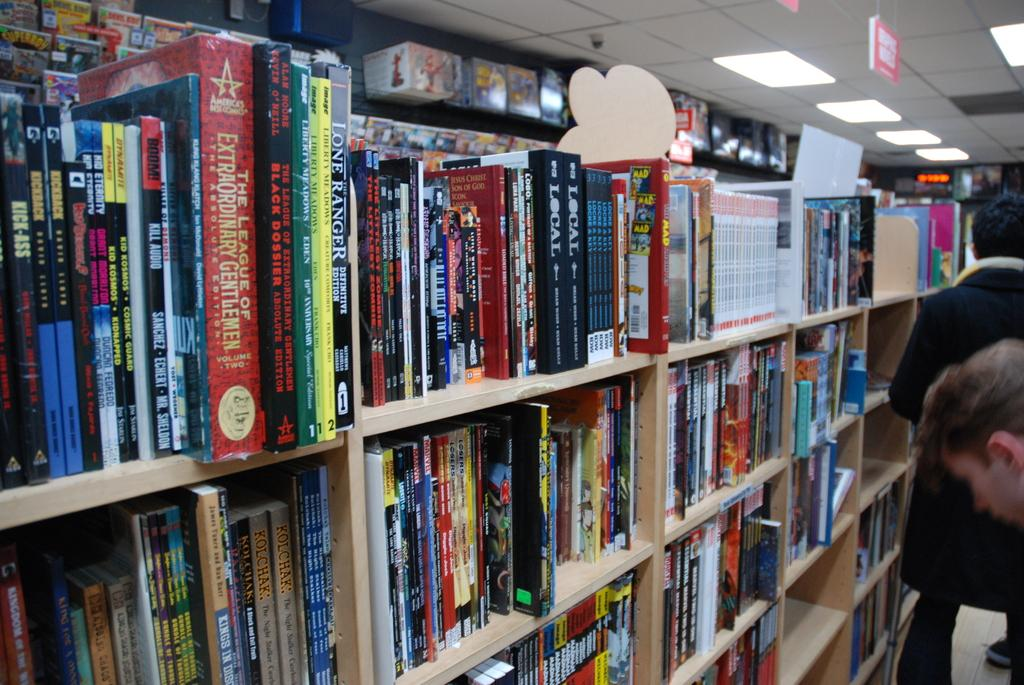<image>
Present a compact description of the photo's key features. Books on shelves and a large red book The League of Extrodinary Gentlemen. 